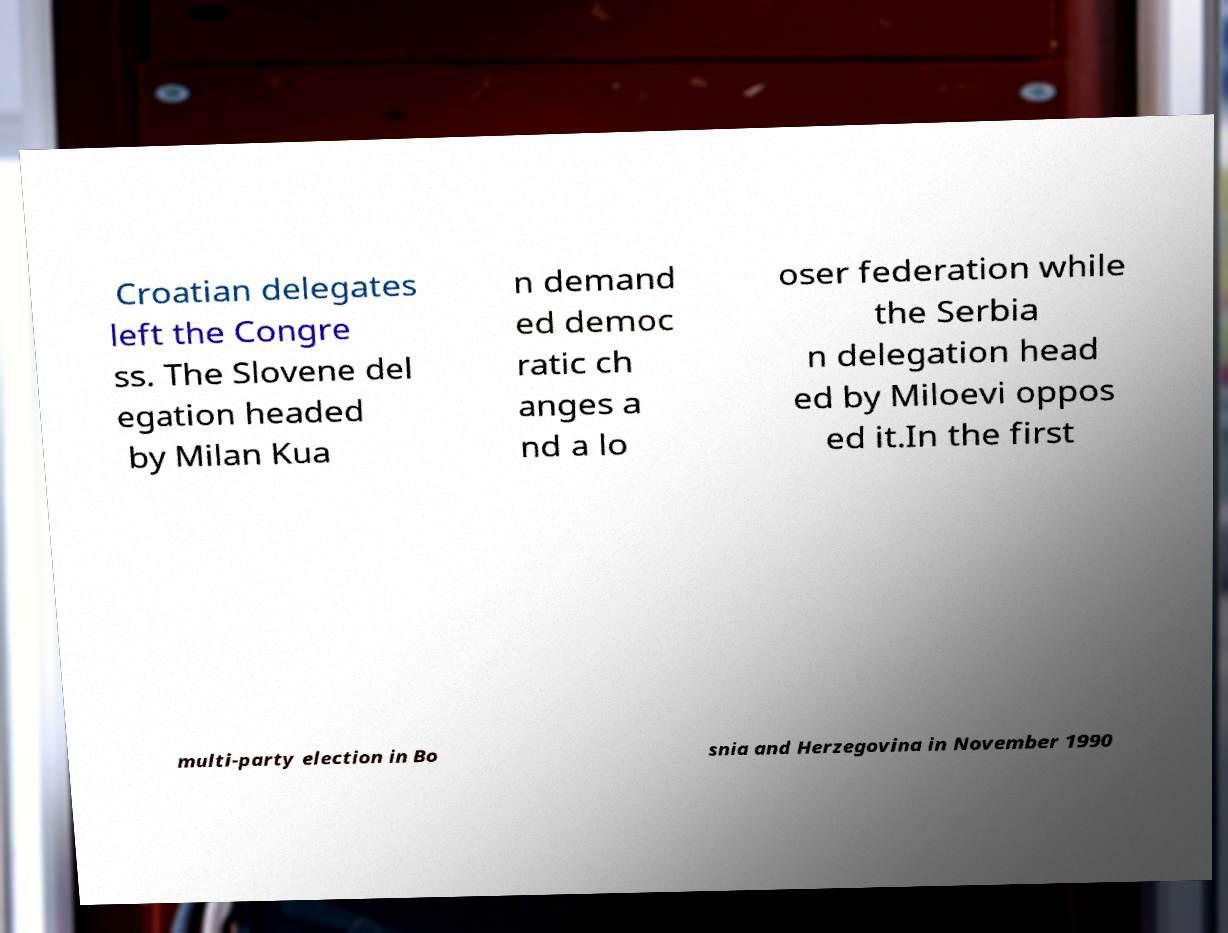There's text embedded in this image that I need extracted. Can you transcribe it verbatim? Croatian delegates left the Congre ss. The Slovene del egation headed by Milan Kua n demand ed democ ratic ch anges a nd a lo oser federation while the Serbia n delegation head ed by Miloevi oppos ed it.In the first multi-party election in Bo snia and Herzegovina in November 1990 